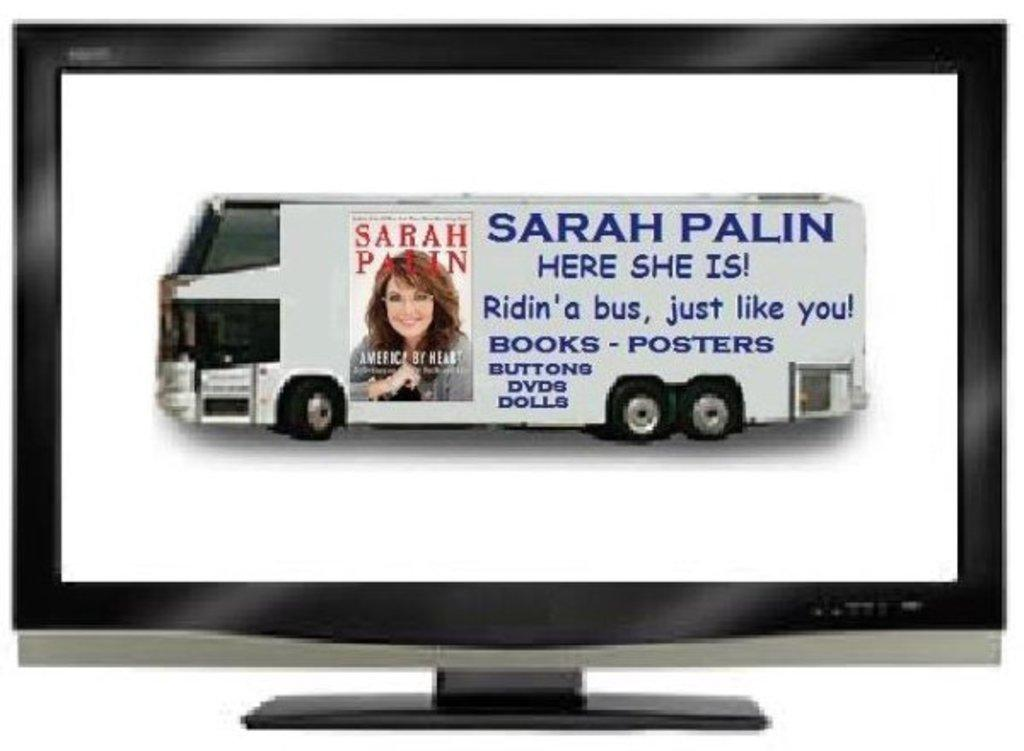<image>
Share a concise interpretation of the image provided. A bus advertises Sarah Palin's book on the side. 